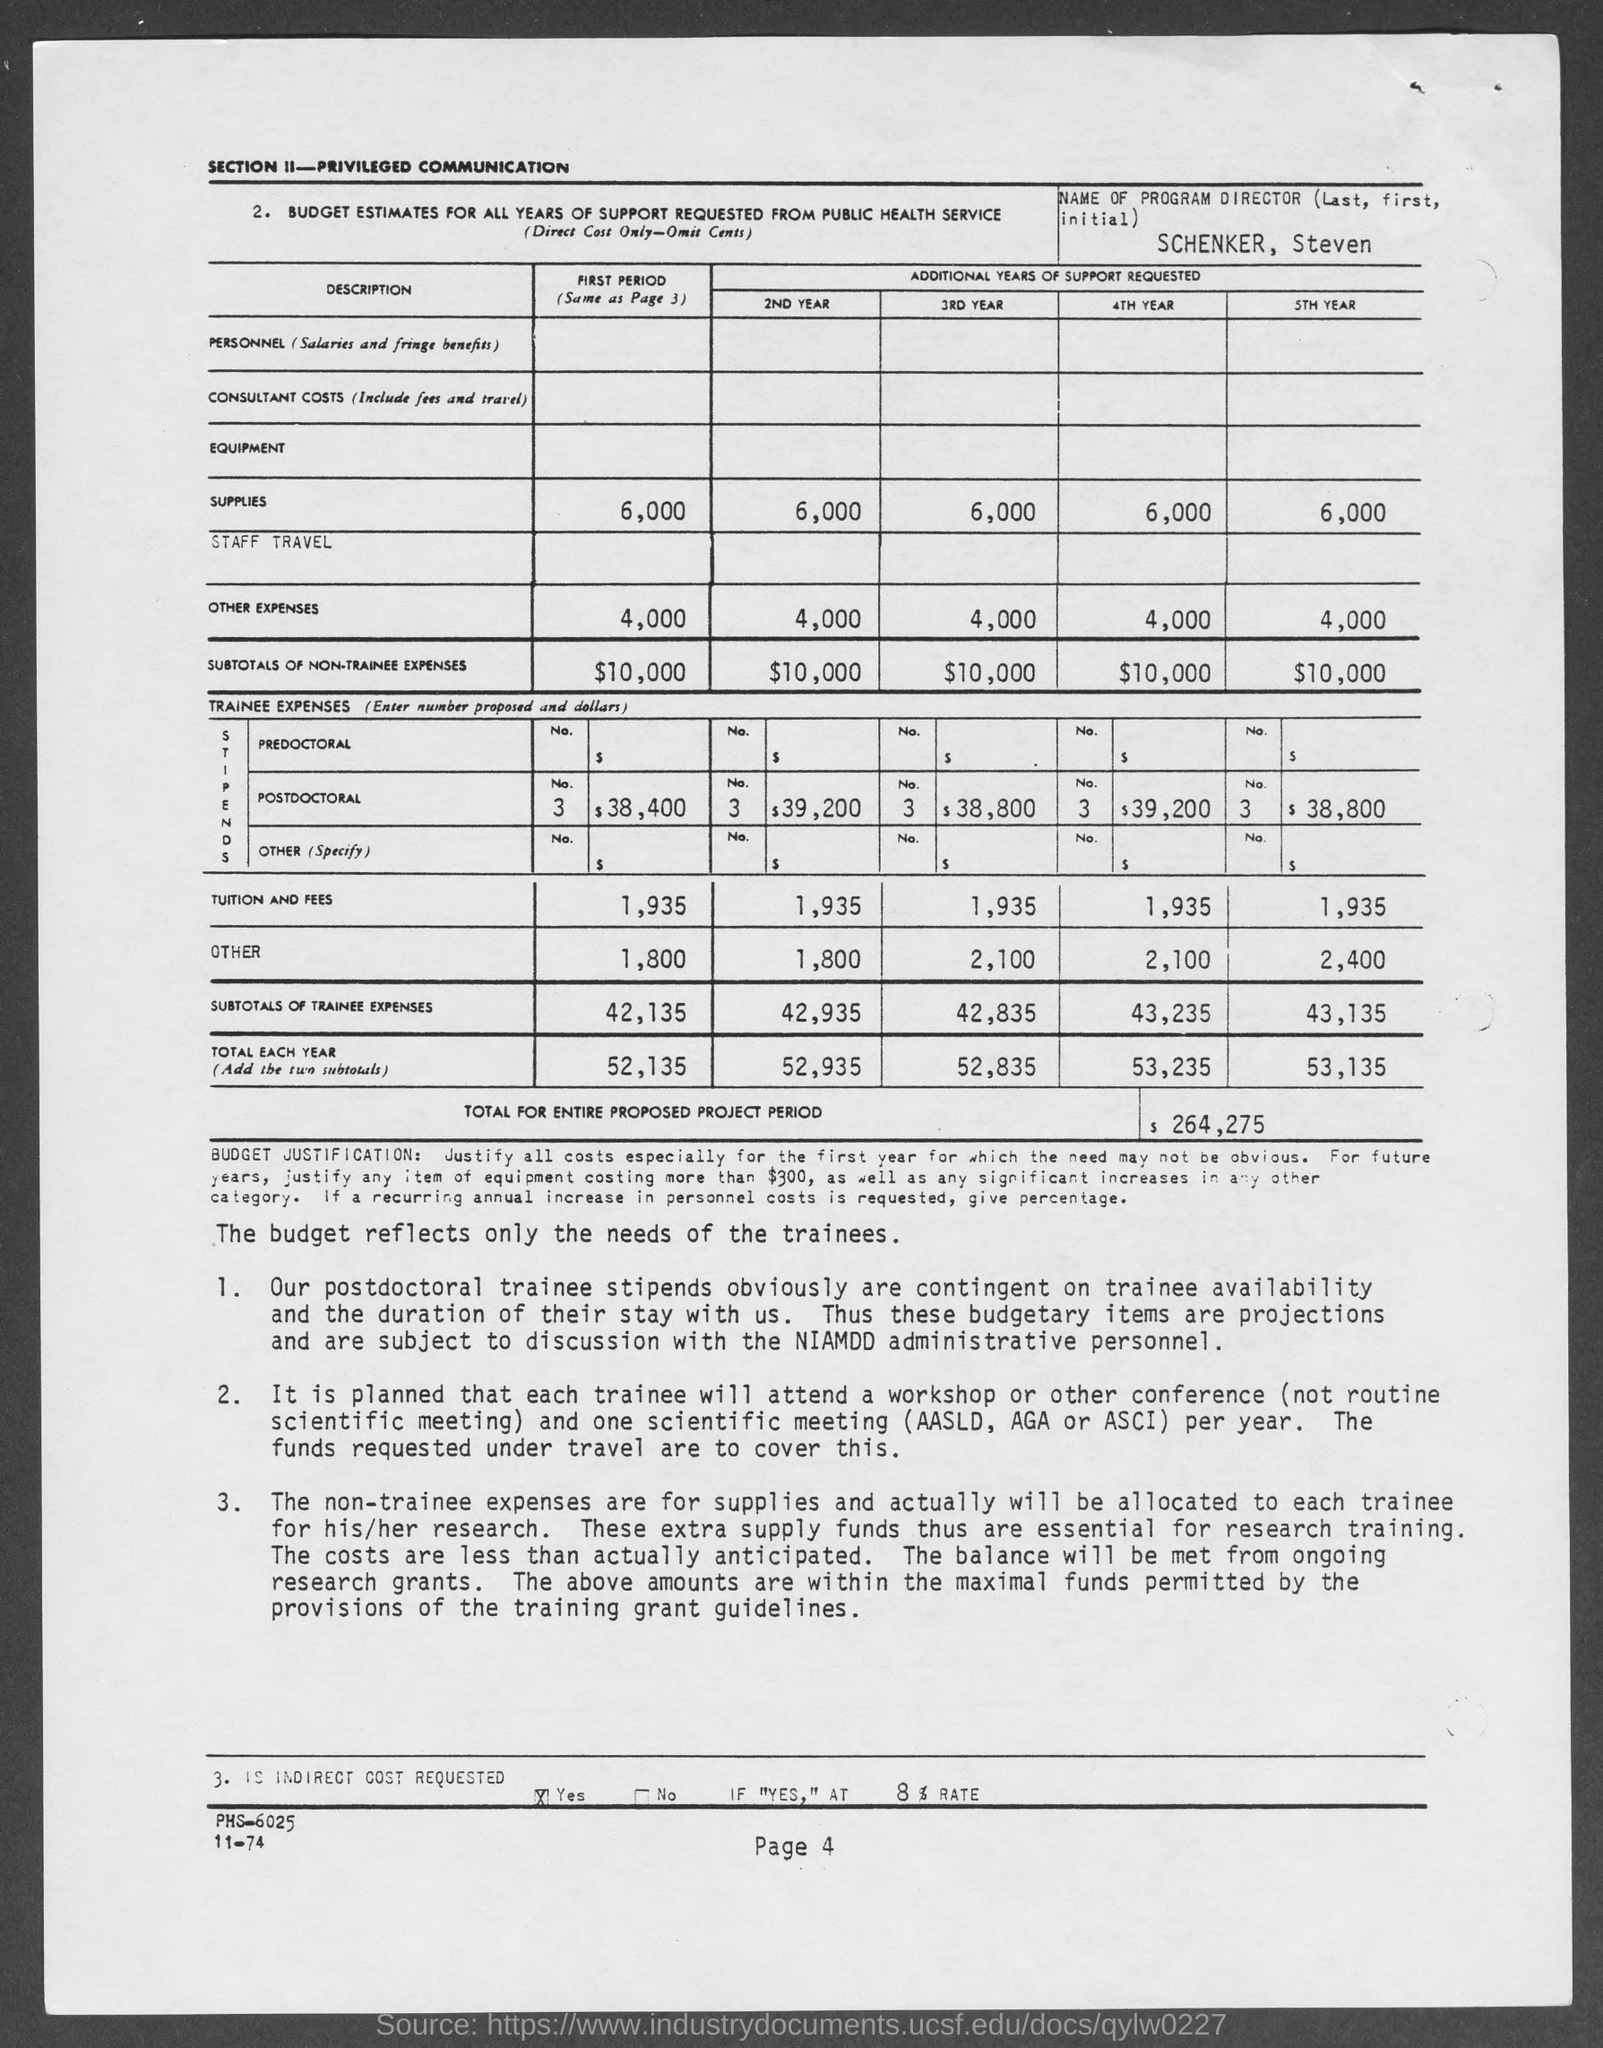What is the name of program director ?
Offer a terse response. Schenker, Steven. What is the page number at bottom of the page?
Offer a very short reply. 4. What is the subtotal of non-trainee expenses in first period?
Your answer should be very brief. $10,000. What is the subtotal of non-trainee expenses in 2nd year?
Your response must be concise. $10,000. What is the subtotal of non-trainee expenses in 3rd year?
Your answer should be very brief. $10,000. What is the subtotal of non-trainee expenses in 4th year ?
Offer a very short reply. $10,000. What is the subtotal of non-trainee expenses in 5th year?
Give a very brief answer. $10,000. What is the total for entire proposed project period ?
Your answer should be very brief. $264,275. 